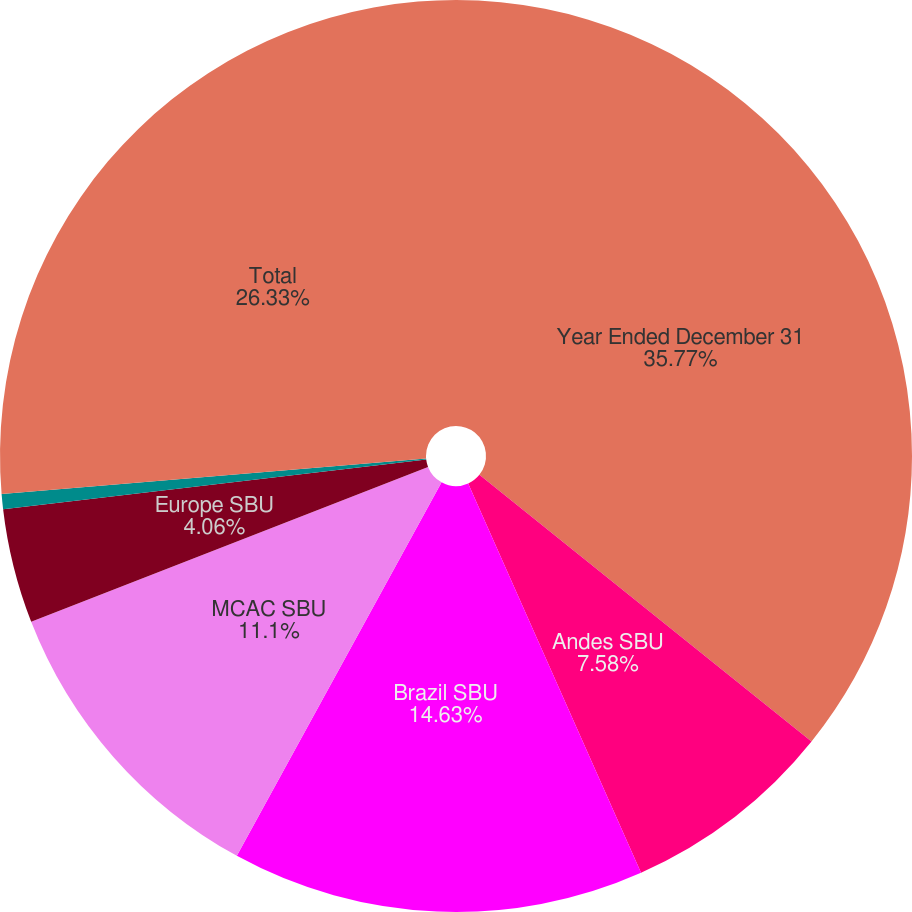<chart> <loc_0><loc_0><loc_500><loc_500><pie_chart><fcel>Year Ended December 31<fcel>Andes SBU<fcel>Brazil SBU<fcel>MCAC SBU<fcel>Europe SBU<fcel>Asia SBU<fcel>Total<nl><fcel>35.77%<fcel>7.58%<fcel>14.63%<fcel>11.1%<fcel>4.06%<fcel>0.53%<fcel>26.33%<nl></chart> 